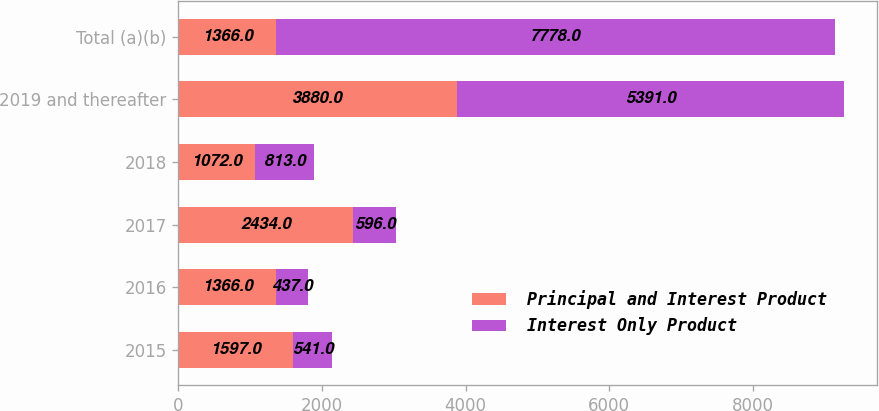Convert chart to OTSL. <chart><loc_0><loc_0><loc_500><loc_500><stacked_bar_chart><ecel><fcel>2015<fcel>2016<fcel>2017<fcel>2018<fcel>2019 and thereafter<fcel>Total (a)(b)<nl><fcel>Principal and Interest Product<fcel>1597<fcel>1366<fcel>2434<fcel>1072<fcel>3880<fcel>1366<nl><fcel>Interest Only Product<fcel>541<fcel>437<fcel>596<fcel>813<fcel>5391<fcel>7778<nl></chart> 